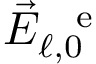<formula> <loc_0><loc_0><loc_500><loc_500>\vec { E } _ { \ell , 0 } ^ { \, e }</formula> 